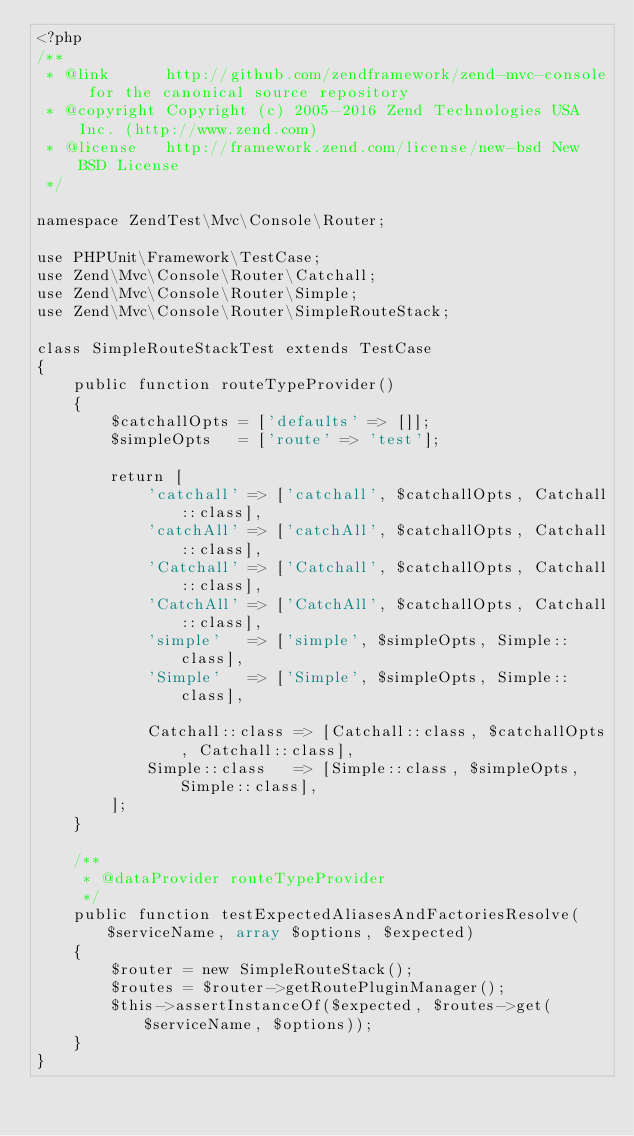<code> <loc_0><loc_0><loc_500><loc_500><_PHP_><?php
/**
 * @link      http://github.com/zendframework/zend-mvc-console for the canonical source repository
 * @copyright Copyright (c) 2005-2016 Zend Technologies USA Inc. (http://www.zend.com)
 * @license   http://framework.zend.com/license/new-bsd New BSD License
 */

namespace ZendTest\Mvc\Console\Router;

use PHPUnit\Framework\TestCase;
use Zend\Mvc\Console\Router\Catchall;
use Zend\Mvc\Console\Router\Simple;
use Zend\Mvc\Console\Router\SimpleRouteStack;

class SimpleRouteStackTest extends TestCase
{
    public function routeTypeProvider()
    {
        $catchallOpts = ['defaults' => []];
        $simpleOpts   = ['route' => 'test'];

        return [
            'catchall' => ['catchall', $catchallOpts, Catchall::class],
            'catchAll' => ['catchAll', $catchallOpts, Catchall::class],
            'Catchall' => ['Catchall', $catchallOpts, Catchall::class],
            'CatchAll' => ['CatchAll', $catchallOpts, Catchall::class],
            'simple'   => ['simple', $simpleOpts, Simple::class],
            'Simple'   => ['Simple', $simpleOpts, Simple::class],

            Catchall::class => [Catchall::class, $catchallOpts, Catchall::class],
            Simple::class   => [Simple::class, $simpleOpts, Simple::class],
        ];
    }

    /**
     * @dataProvider routeTypeProvider
     */
    public function testExpectedAliasesAndFactoriesResolve($serviceName, array $options, $expected)
    {
        $router = new SimpleRouteStack();
        $routes = $router->getRoutePluginManager();
        $this->assertInstanceOf($expected, $routes->get($serviceName, $options));
    }
}
</code> 